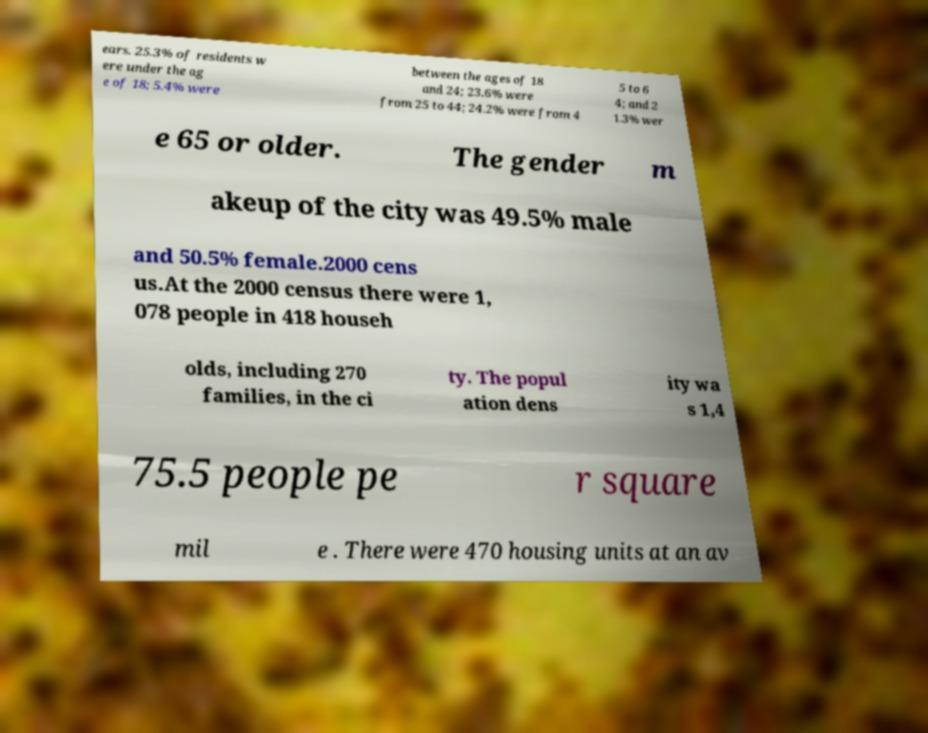Could you assist in decoding the text presented in this image and type it out clearly? ears. 25.3% of residents w ere under the ag e of 18; 5.4% were between the ages of 18 and 24; 23.6% were from 25 to 44; 24.2% were from 4 5 to 6 4; and 2 1.3% wer e 65 or older. The gender m akeup of the city was 49.5% male and 50.5% female.2000 cens us.At the 2000 census there were 1, 078 people in 418 househ olds, including 270 families, in the ci ty. The popul ation dens ity wa s 1,4 75.5 people pe r square mil e . There were 470 housing units at an av 